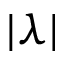Convert formula to latex. <formula><loc_0><loc_0><loc_500><loc_500>| \lambda |</formula> 